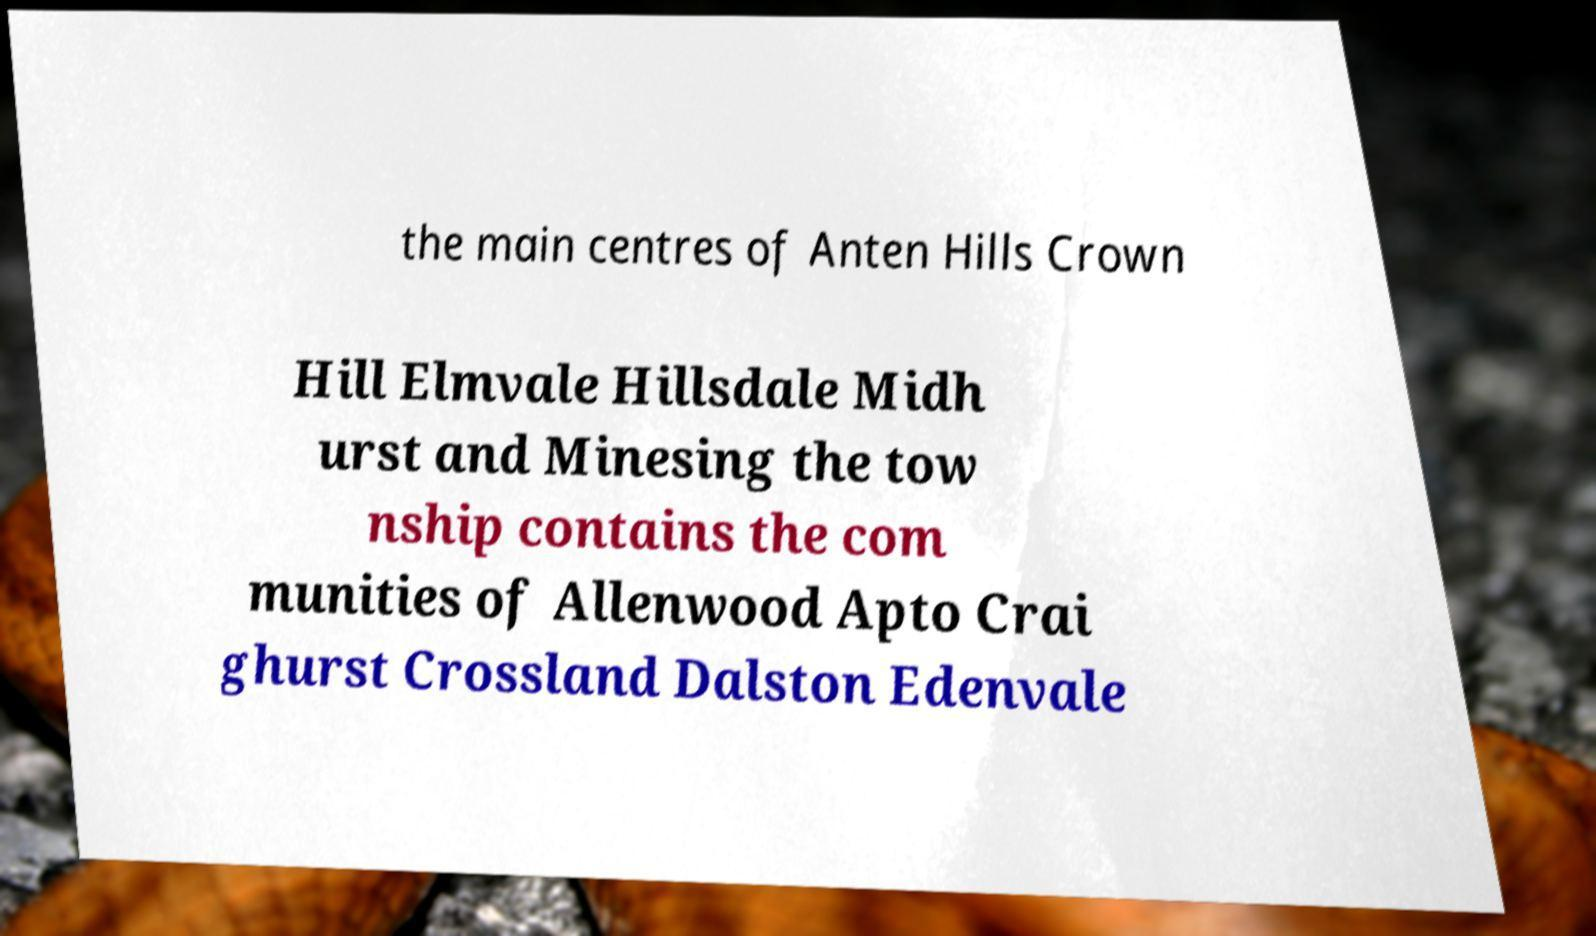Please read and relay the text visible in this image. What does it say? the main centres of Anten Hills Crown Hill Elmvale Hillsdale Midh urst and Minesing the tow nship contains the com munities of Allenwood Apto Crai ghurst Crossland Dalston Edenvale 